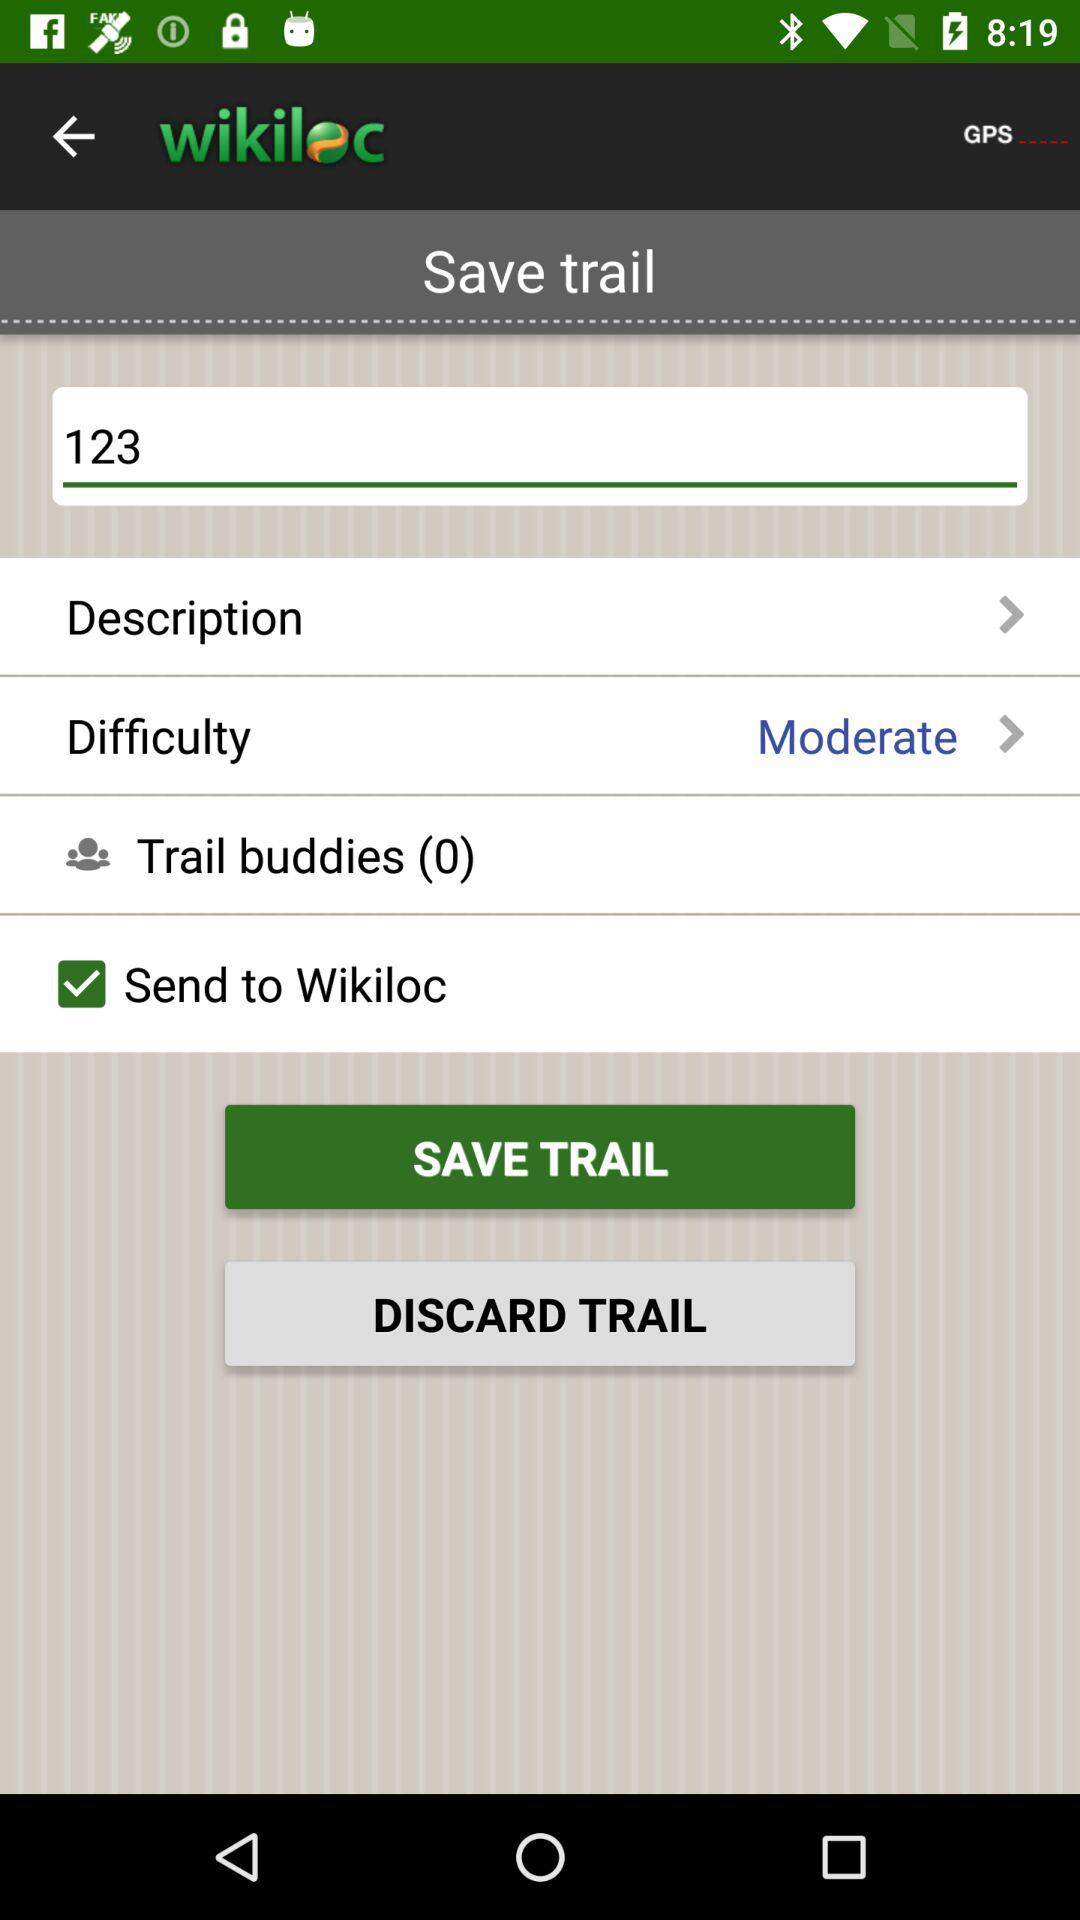How many trail buddies does the user have?
Answer the question using a single word or phrase. 0 